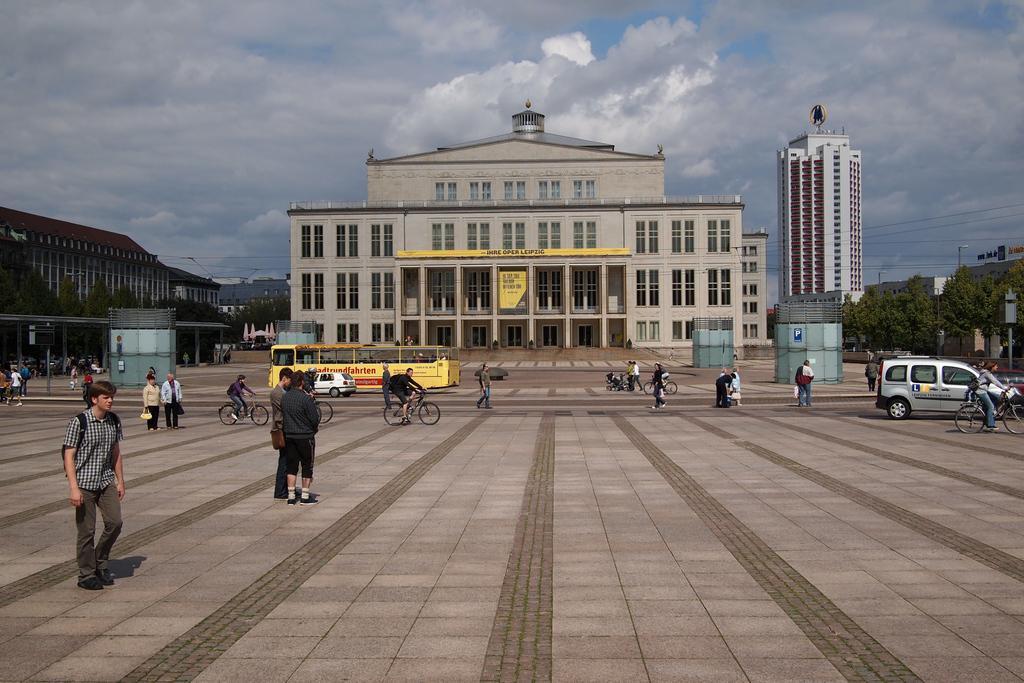Can you describe this image briefly? In the background we can see sky with clouds, buildings and trees. Here we can see a bus and cars. We can see few people standing, walking. Few people are riding bicycles. 